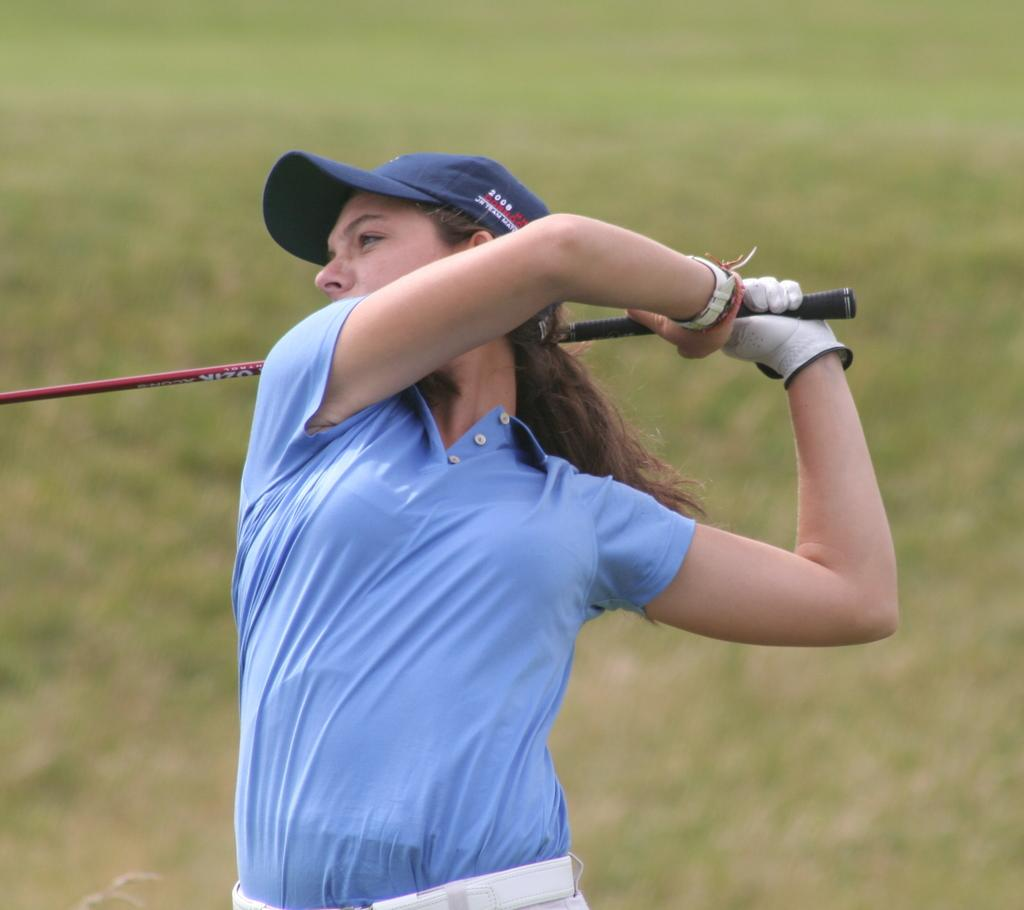Who is present in the image? There is a woman in the image. What is the woman doing in the image? The woman is standing in the image. What object is the woman holding in the image? The woman is holding a stick in the image. What type of environment can be seen in the background of the image? There is grass visible in the background of the image. How many children are laughing in the image? There are no children or laughter present in the image; it features a woman standing and holding a stick. What type of lizards can be seen crawling on the grass in the image? There are no lizards visible in the image; only the woman and the grass are present. 